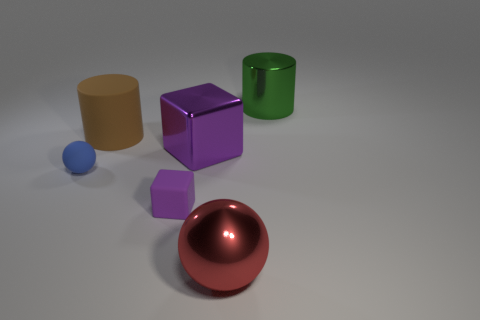Subtract all blue balls. How many balls are left? 1 Subtract all green balls. How many cyan cubes are left? 0 Subtract all purple metallic things. Subtract all small purple matte cubes. How many objects are left? 4 Add 5 brown matte objects. How many brown matte objects are left? 6 Add 3 green metallic balls. How many green metallic balls exist? 3 Add 1 blue objects. How many objects exist? 7 Subtract 0 cyan cubes. How many objects are left? 6 Subtract all spheres. How many objects are left? 4 Subtract all red blocks. Subtract all gray spheres. How many blocks are left? 2 